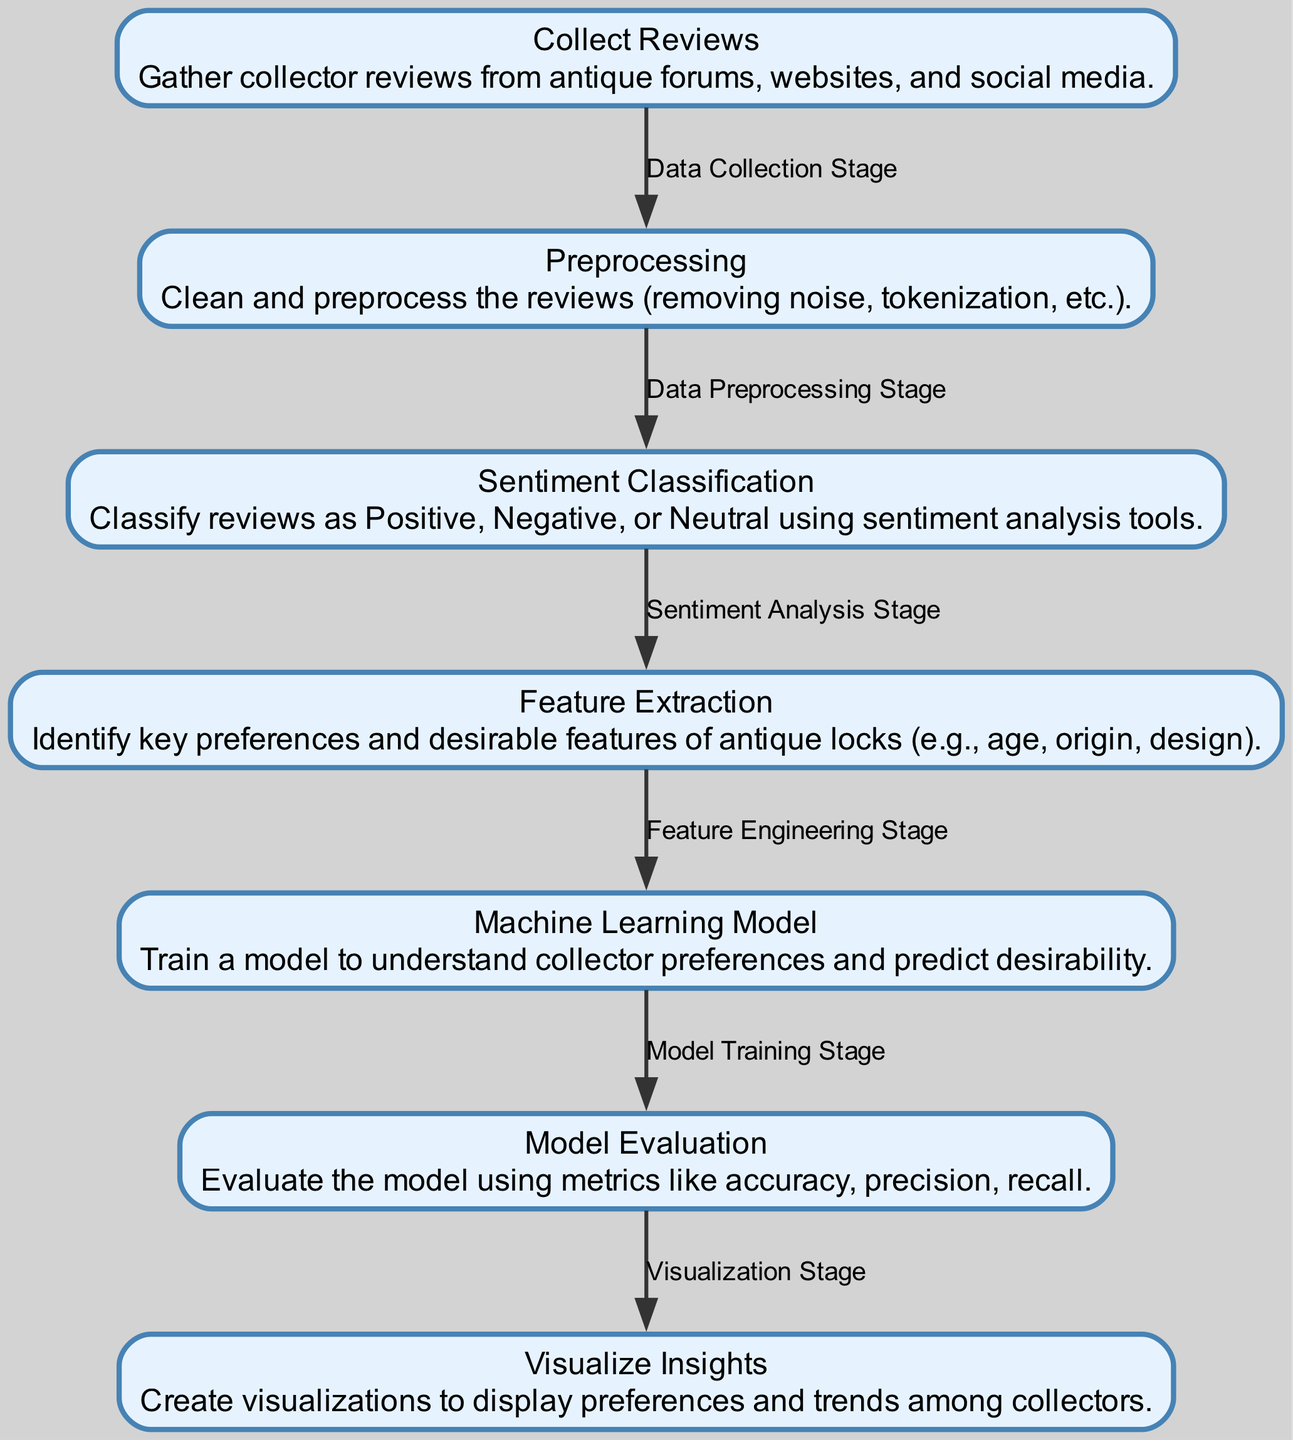What is the first step in the process? The diagram indicates that the initial step is "Collect Reviews," which involves gathering information from various sources.
Answer: Collect Reviews How many nodes are there in the diagram? By counting the listed nodes in the diagram, I can determine that there are a total of seven distinct steps or stages represented.
Answer: 7 What are the key features identified in the "Feature Extraction" stage? The "Feature Extraction" stage focuses on identifying key preferences and desirable features of antique locks, such as age, origin, and design.
Answer: Age, origin, design Which node follows "Sentiment Classification"? The “Feature Extraction” node is directly after the “Sentiment Classification” node in the flow of the diagram.
Answer: Feature Extraction What is the purpose of the "Model Evaluation" node? The “Model Evaluation” node is tasked with assessing the machine learning model using metrics such as accuracy, precision, and recall, thereby ensuring its effectiveness.
Answer: Evaluate the model How does "Preprocessing" contribute to sentiment analysis? "Preprocessing" prepares the data by cleaning and organizing it, which is crucial for accurate sentiment classification; without clean data, predictions may be incorrect.
Answer: Data quality improvement What is the final output of the process according to the diagram? The last node in the sequence is “Visualize Insights,” suggesting that the outcome is visual representations of preferences and trends among collectors.
Answer: Visualize Insights Which stages involve modeling in the process? The "Machine Learning Model" and "Model Evaluation" stages are the two parts of the process that directly involve modeling, as one is for training and the other for assessing the model.
Answer: Model training, Model evaluation What relationship exists between "Collect Reviews" and "Preprocessing"? The edge labeled "Data Collection Stage" indicates that "Collect Reviews" leads directly into the "Preprocessing" stage, marking it as the first step in data handling.
Answer: Data Collection Stage 